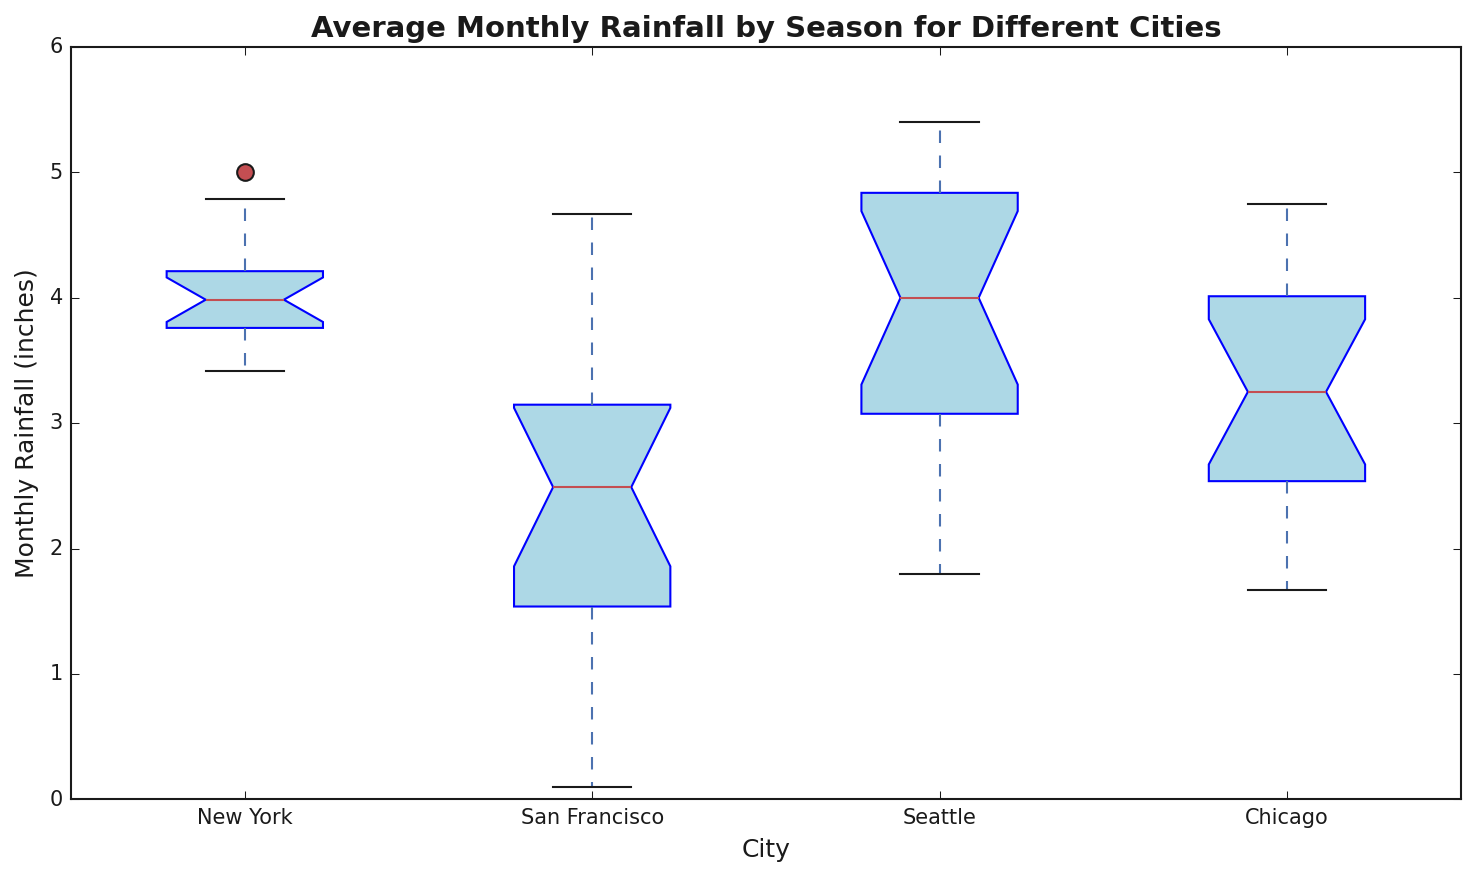What season has the highest median rainfall in New York? Look at the box plots for New York by season and identify which season has the highest central line inside the box (median).
Answer: Summer Which city has the lowest median monthly rainfall in summer? Look at the boxplots for the summer season and identify which city has the lowest central line inside the box.
Answer: San Francisco Is the median rainfall higher in Spring or Autumn for New York? Compare the height of the central lines (medians) in the boxplots for Spring and Autumn in New York.
Answer: Spring Which city shows the greatest range of monthly rainfall in winter? To find the range, observe the distances between the top and bottom whiskers in the box plots for winter in each city. The longest distance represents the greatest range.
Answer: Seattle Is there any season where New York has a lower median rainfall than Chicago? If so, which one? Compare the height of central lines (medians) in the box plots for each season for New York and Chicago. Check if any season in New York has a lower median than Chicago.
Answer: No For which city is the difference between the maximum and minimum rainfall largest in Autumn? Inspect the distance between the whiskers for each city's Autumn box plot and identify the longest distance.
Answer: Seattle What season in San Francisco has the least variation in monthly rainfall? Look for the box plot with the narrowest interquartile range (the length of the box) for each season in San Francisco.
Answer: Summer Comparing Winter rainfall medians, which city appears to be the driest? Compare the heights of the central lines (medians) in the Winter box plots for all cities. Identify the lowest line.
Answer: Chicago Which city has more outliers in their Summer rainfall data? Outliers are represented by points outside the whiskers. Count the outliers for the Summer season in each city's box plot.
Answer: San Francisco In which season does Seattle have approximately the same median rainfall as New York? Compare the heights of the central lines of Seattle's and New York's box plots across the seasons to find a similar level.
Answer: Autumn 